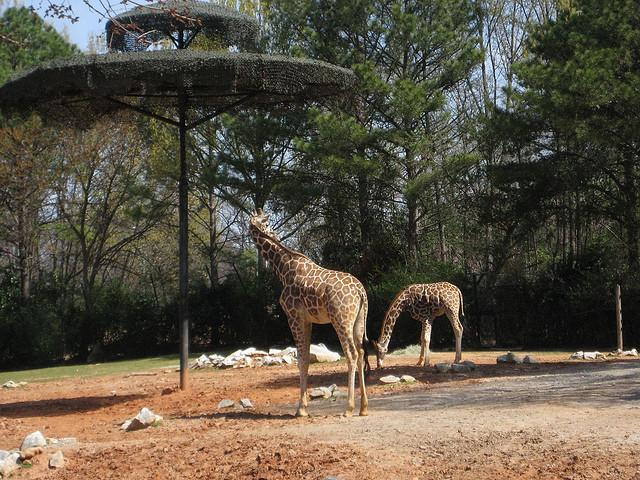What is the umbrella topped structure on the right supposed to resemble? Please explain your reasoning. tree. The umbrella is covered in fake leaves. 